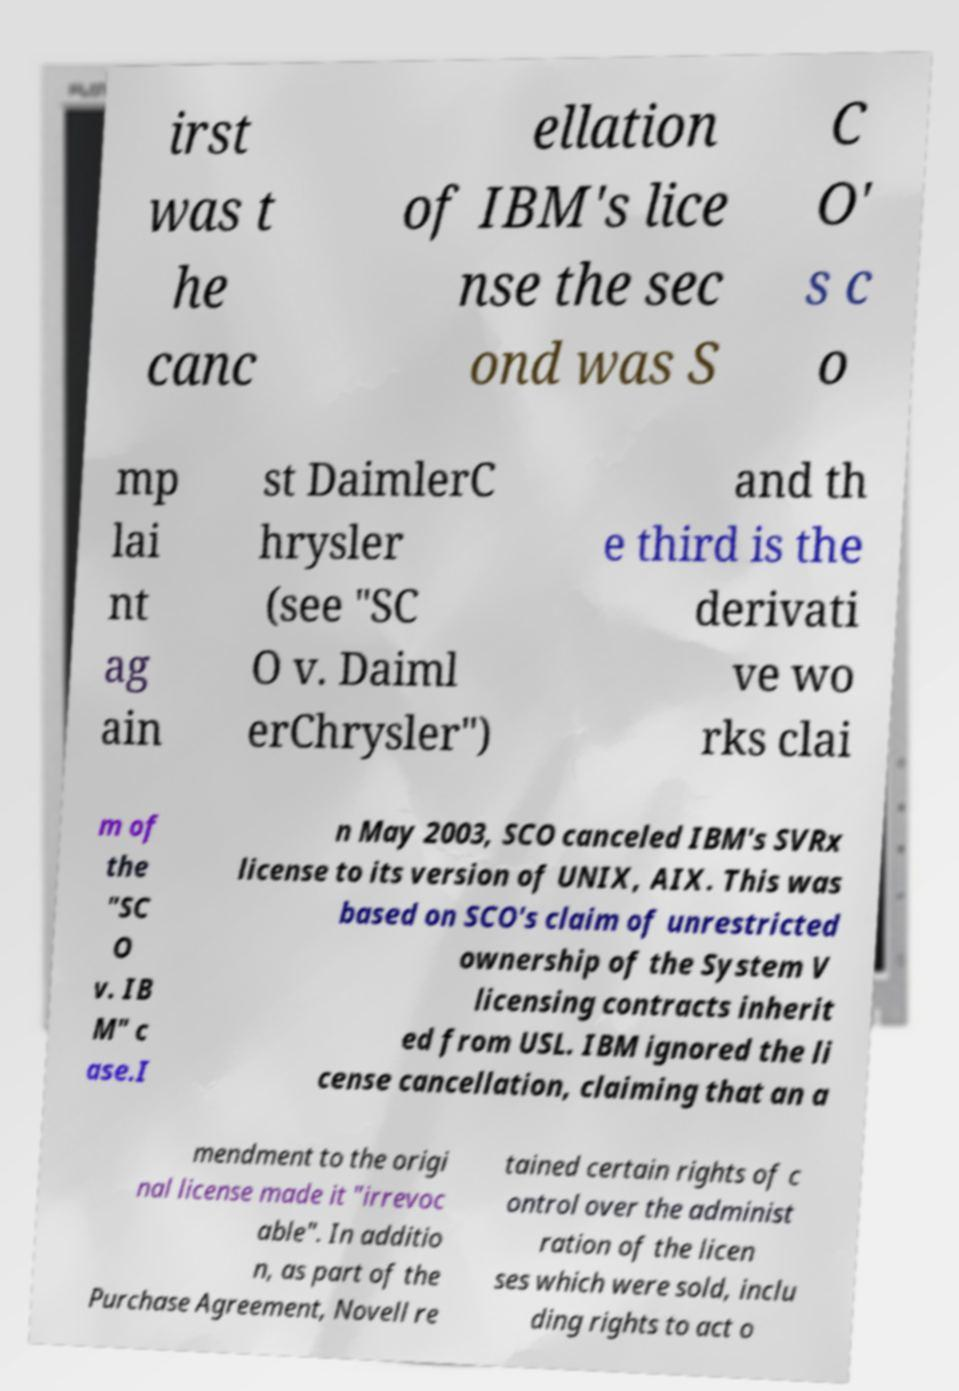There's text embedded in this image that I need extracted. Can you transcribe it verbatim? irst was t he canc ellation of IBM's lice nse the sec ond was S C O' s c o mp lai nt ag ain st DaimlerC hrysler (see "SC O v. Daiml erChrysler") and th e third is the derivati ve wo rks clai m of the "SC O v. IB M" c ase.I n May 2003, SCO canceled IBM's SVRx license to its version of UNIX, AIX. This was based on SCO's claim of unrestricted ownership of the System V licensing contracts inherit ed from USL. IBM ignored the li cense cancellation, claiming that an a mendment to the origi nal license made it "irrevoc able". In additio n, as part of the Purchase Agreement, Novell re tained certain rights of c ontrol over the administ ration of the licen ses which were sold, inclu ding rights to act o 